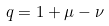<formula> <loc_0><loc_0><loc_500><loc_500>q = 1 + \mu - \nu</formula> 